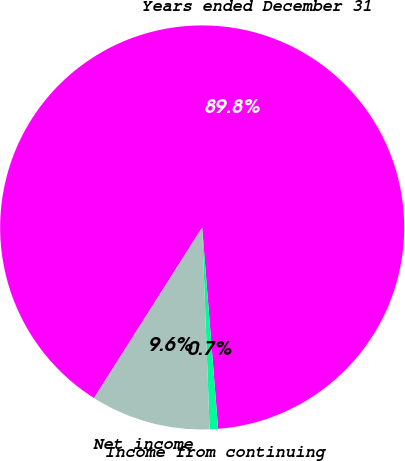Convert chart to OTSL. <chart><loc_0><loc_0><loc_500><loc_500><pie_chart><fcel>Years ended December 31<fcel>Income from continuing<fcel>Net income<nl><fcel>89.75%<fcel>0.67%<fcel>9.58%<nl></chart> 